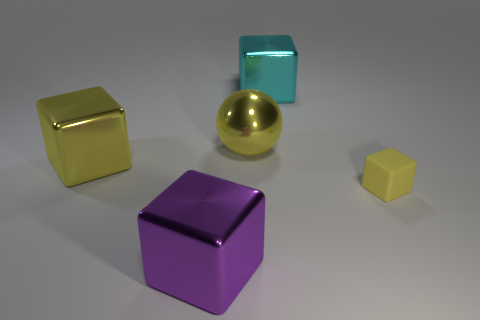Subtract all small yellow rubber cubes. How many cubes are left? 3 Add 3 tiny brown matte cylinders. How many objects exist? 8 Subtract all purple blocks. How many blocks are left? 3 Subtract 1 spheres. How many spheres are left? 0 Subtract all cubes. How many objects are left? 1 Add 5 purple metal things. How many purple metal things exist? 6 Subtract 0 green cylinders. How many objects are left? 5 Subtract all purple cubes. Subtract all green cylinders. How many cubes are left? 3 Subtract all yellow blocks. How many purple balls are left? 0 Subtract all big things. Subtract all tiny green rubber objects. How many objects are left? 1 